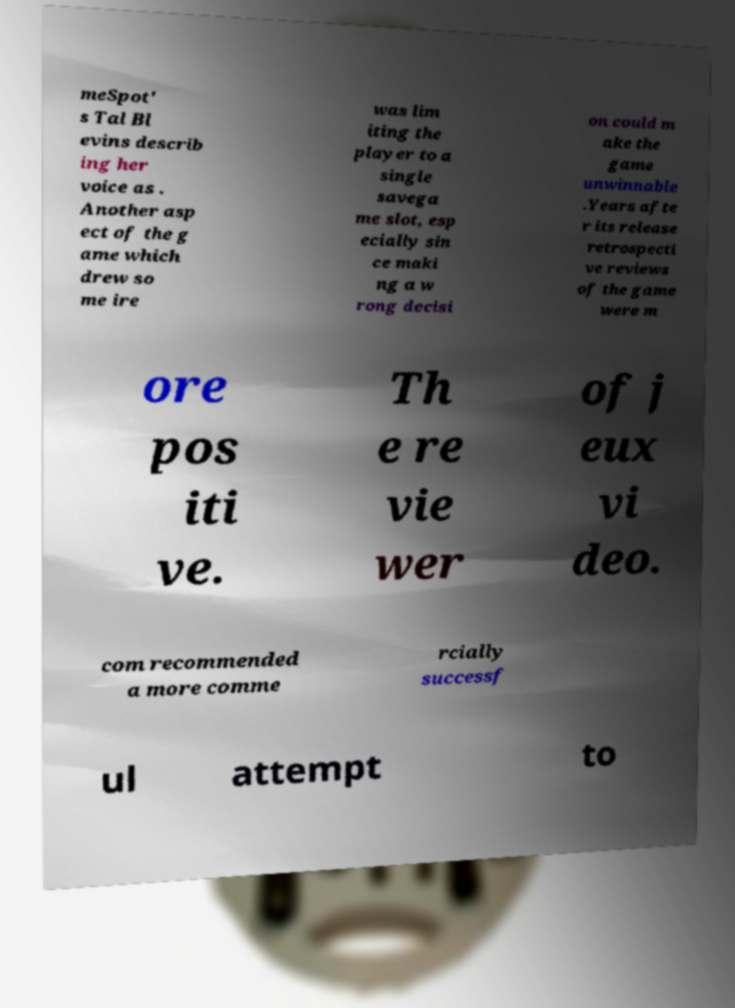Can you read and provide the text displayed in the image?This photo seems to have some interesting text. Can you extract and type it out for me? meSpot' s Tal Bl evins describ ing her voice as . Another asp ect of the g ame which drew so me ire was lim iting the player to a single savega me slot, esp ecially sin ce maki ng a w rong decisi on could m ake the game unwinnable .Years afte r its release retrospecti ve reviews of the game were m ore pos iti ve. Th e re vie wer of j eux vi deo. com recommended a more comme rcially successf ul attempt to 